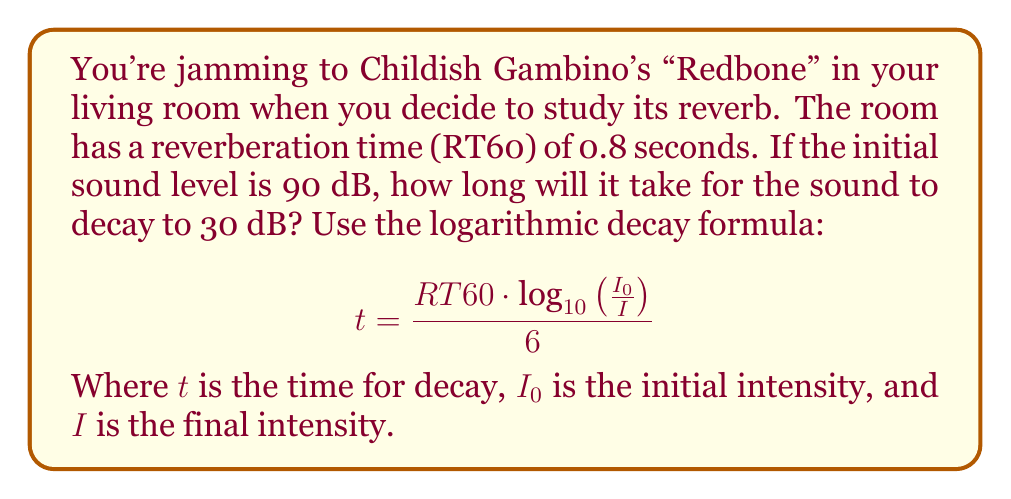Can you solve this math problem? To solve this problem, we'll use the given formula and follow these steps:

1) We know:
   - RT60 = 0.8 seconds
   - Initial level = 90 dB
   - Final level = 30 dB

2) The formula uses intensity ratio, not decibels. We need to convert the dB difference to an intensity ratio:
   
   Intensity ratio = $10^{\frac{dB difference}{10}}$ = $10^{\frac{90-30}{10}}$ = $10^6$

3) Now we can plug the values into the formula:

   $$t = \frac{0.8 \cdot \log_{10}(10^6)}{6}$$

4) Simplify inside the logarithm:
   
   $$t = \frac{0.8 \cdot 6}{6}$$

5) Calculate:
   
   $$t = 0.8 \text{ seconds}$$

Thus, it will take 0.8 seconds for the sound to decay from 90 dB to 30 dB in this room.
Answer: 0.8 seconds 